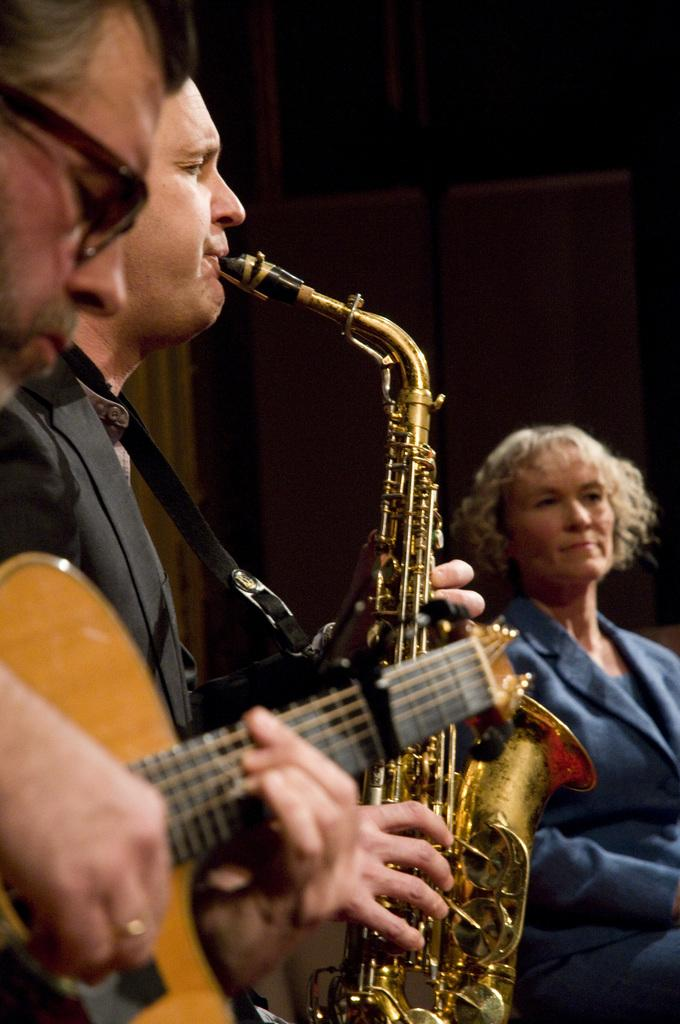How many people are in the image? There are three members in the image. Can you describe the gender of the people in the image? Two of them are men. What are the men doing in the image? The men are playing musical instruments. What is the color of the background in the image? The background of the image is dark. What type of books can be seen in the library in the image? There is no library present in the image, so it is not possible to determine what type of books might be seen. 